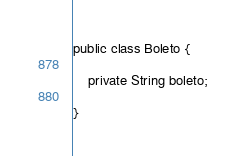Convert code to text. <code><loc_0><loc_0><loc_500><loc_500><_Java_>public class Boleto {
    
    private String boleto;
    
}
</code> 